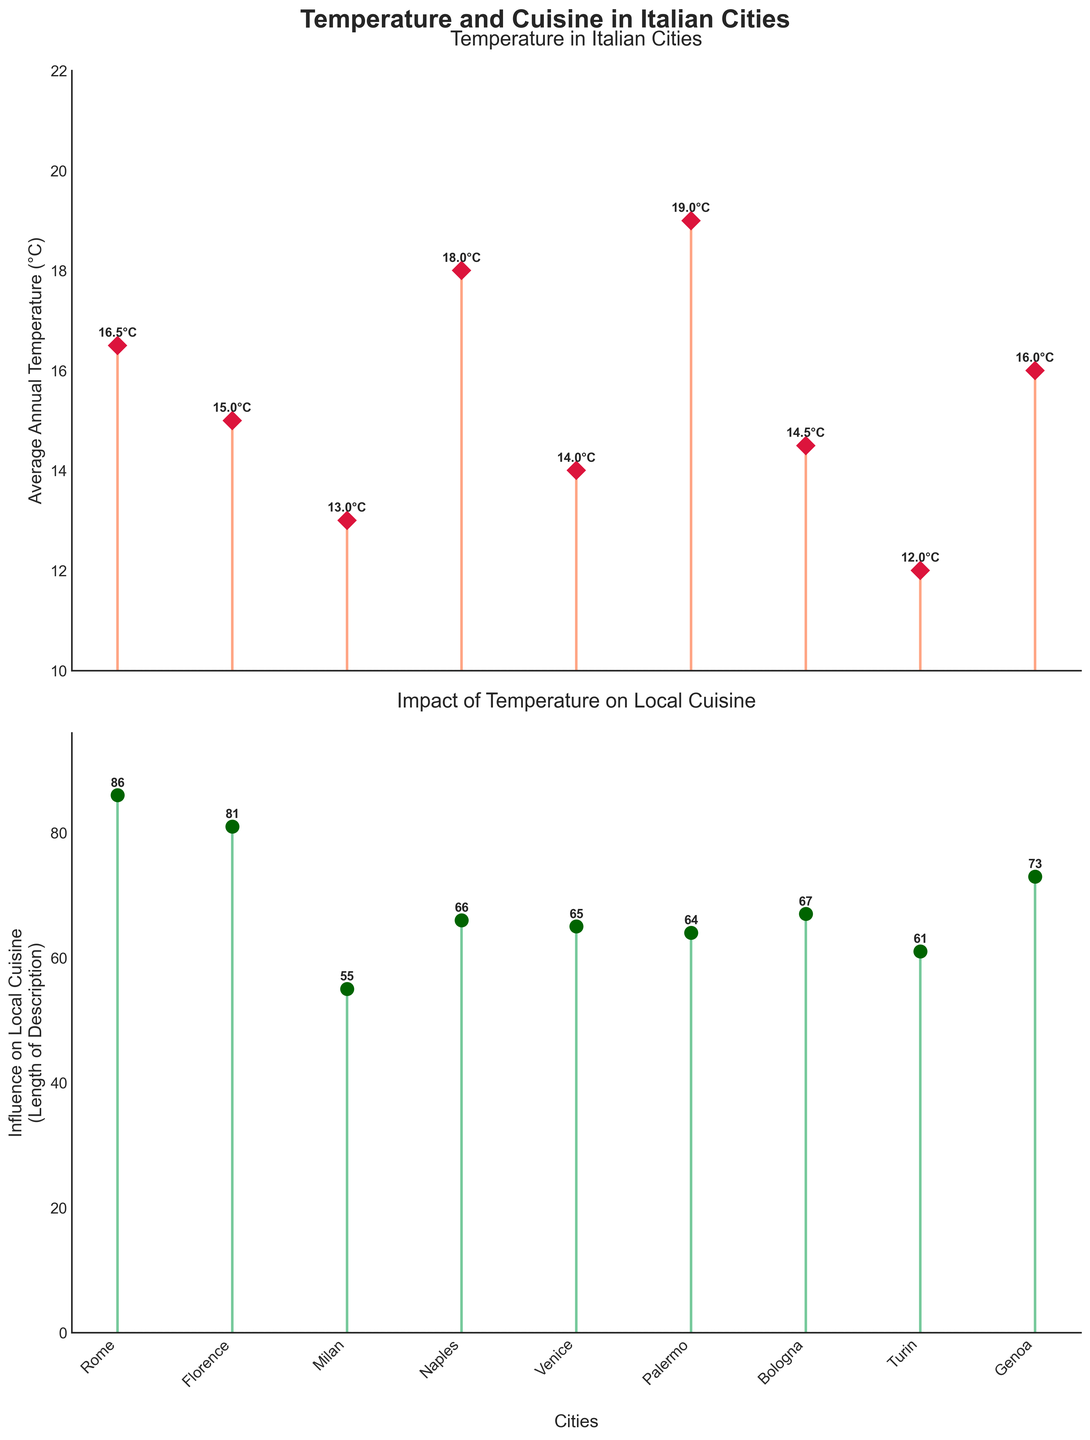What is the average annual temperature in Milan? The first subplot shows the average annual temperature for each city. For Milan, the value is 13.0°C.
Answer: 13.0°C Which city has the highest average annual temperature? The first subplot shows the temperatures for each city. Palermo has the highest temperature at 19.0°C.
Answer: Palermo How does the influence of temperature on local cuisine in Genoa compare to that in Turin? The second subplot shows the influence of temperature on local cuisine. The length of the description (represented by the y-value) for Genoa is longer than that for Turin.
Answer: Higher in Genoa Which city has the most significant temperature influence on its cuisine, based on description length? The second subplot shows the lengths of the influence descriptions. Venice has the longest description, indicating the most significant influence.
Answer: Venice What is the difference in average annual temperature between Naples and Turin? The temperature for Naples is 18.0°C, and for Turin, it is 12.0°C. The difference is 18.0 - 12.0 = 6.0°C.
Answer: 6.0°C Among Rome, Florence, and Milan, which city has the highest average annual temperature? The first subplot shows the temperatures for each city. Rome has the highest temperature at 16.5°C, compared to 15.0°C for Florence and 13.0°C for Milan.
Answer: Rome How does the climate in Bologna influence its local cuisine? The first subplot shows Bologna's temperature at 14.5°C. According to the descriptions, Bologna's balanced climate supports rich pasta dishes with slow-cooked meats.
Answer: Balanced climate supports rich pasta dishes Which city has the lowest average annual temperature, and what is its signature dish? The first subplot shows that Turin has the lowest temperature at 12.0°C. The data indicates the signature dish is Bagna Cauda.
Answer: Turin, Bagna Cauda 